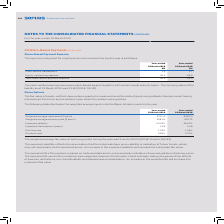According to Sophos Group's financial document, What assumption is reflected by the expected volatility? assumption that the historical share price volatility is indicative of future trends, which may not necessarily be the actual outcome. An increase in the expected volatility will increase the estimated fair value.. The document states: "The expected volatility reflects the assumption that the historical share price volatility is indicative of future trends, which may not necessarily b..." Also, What is the expected life of the options based on? historical data and is not necessarily indicative of exercise patterns that may occur. The expected life used in the model has been adjusted, based on the Director’s best estimate, taking into account the effects of exercise restrictions, non-transferability and behavioural considerations. An increase in the expected life will increase the estimated fair value.. The document states: "The expected life of the options is based on historical data and is not necessarily indicative of exercise patterns that may occur. The expected life ..." Also, For which years are the weighted average inputs into the Black-Scholes model considered?  The document shows two values: 2019 and 2018. From the document: "Year-ended 31 March 2019 Year-ended 31 March 2018 Year-ended 31 March 2019 Year-ended 31 March 2018..." Additionally, In which year was the Weighted average share price larger? According to the financial document, 2019. The relevant text states: "Year-ended 31 March 2019 Year-ended 31 March 2018..." Also, can you calculate: What was the change in Weighted average share price in 2019 from 2018? Based on the calculation: 676.10-628.23, the result is 47.87. This is based on the information: "Weighted average share price ($ cents) 676.10 628.23 Weighted average share price ($ cents) 676.10 628.23..." The key data points involved are: 628.23, 676.10. Also, can you calculate: What was the percentage change in Weighted average share price in 2019 from 2018? To answer this question, I need to perform calculations using the financial data. The calculation is: (676.10-628.23)/628.23, which equals 7.62 (percentage). This is based on the information: "Weighted average share price ($ cents) 676.10 628.23 Weighted average share price ($ cents) 676.10 628.23..." The key data points involved are: 628.23, 676.10. 